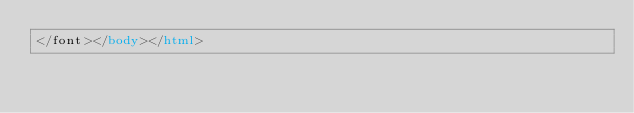<code> <loc_0><loc_0><loc_500><loc_500><_HTML_></font></body></html></code> 